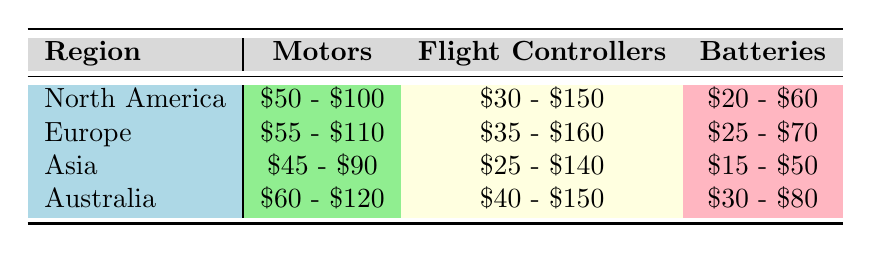What is the price range for Flight Controllers in North America? According to the table under the North America row, the price range for Flight Controllers is listed as $30 - $150.
Answer: $30 - $150 Which region has the highest price range for Motors? Looking at the Motors column across the various regions, Australia has the price range of $60 - $120, which is greater than North America ($50 - $100), Europe ($55 - $110), and Asia ($45 - $90).
Answer: Australia Is the price range for Batteries in Asia lower than that in North America? The price range for Batteries in Asia is $15 - $50, while in North America it is $20 - $60. Since the lower end of Asia’s range ($15) is lower than North America's ($20), the overall price range in Asia is indeed lower.
Answer: Yes What is the average price range for Flight Controllers across all regions? To find the average price range, we need to consider the ranges: North America ($30 - $150), Europe ($35 - $160), Asia ($25 - $140), and Australia ($40 - $150). We calculate the average of the lower bounds: (30 + 35 + 25 + 40)/4 = 32.5, and for the upper bounds: (150 + 160 + 140 + 150)/4 = 150. The average price range is then $32.5 - $150, but we can only take integer ranges into account, therefore it does not fall under a standard range.
Answer: $32.5 - $150 Which type of component has the largest price range in the Australia region? For Australia, Motors are priced $60 - $120, Flight Controllers $40 - $150, and Batteries $30 - $80. The range for Flight Controllers ($40 - $150) shows the largest difference (110), compared to the others as Motors have a range difference of 60 and Batteries 50.
Answer: Flight Controllers 